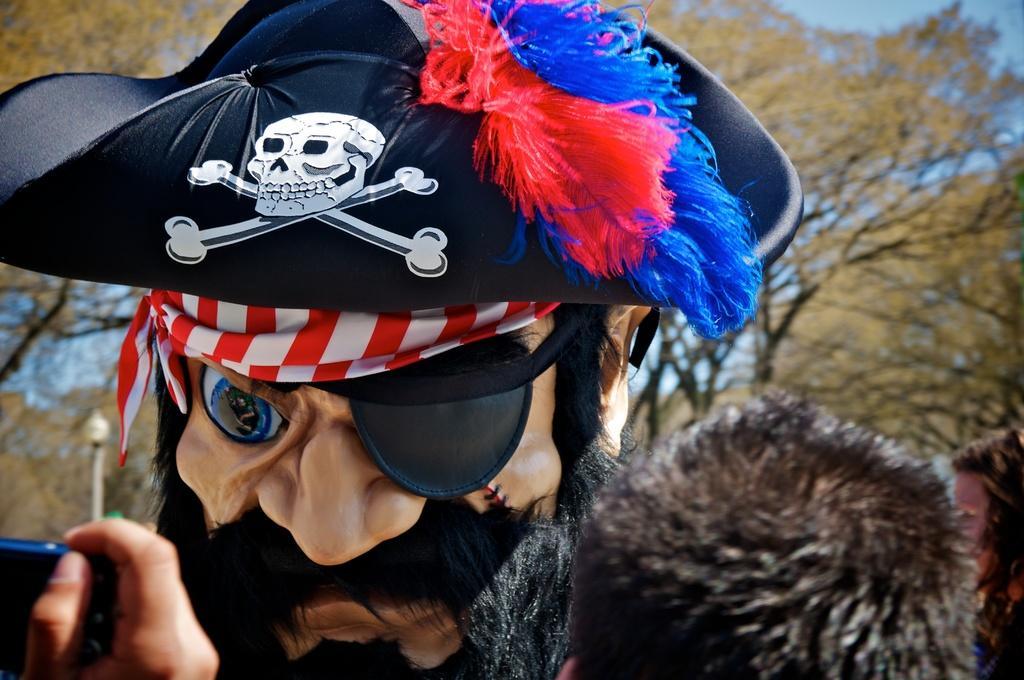Please provide a concise description of this image. In this picture I can see there is a pirate costume and there are a few people standing around him and clicking the images. There are few trees and a pole in the backdrop and the sky is clear. 